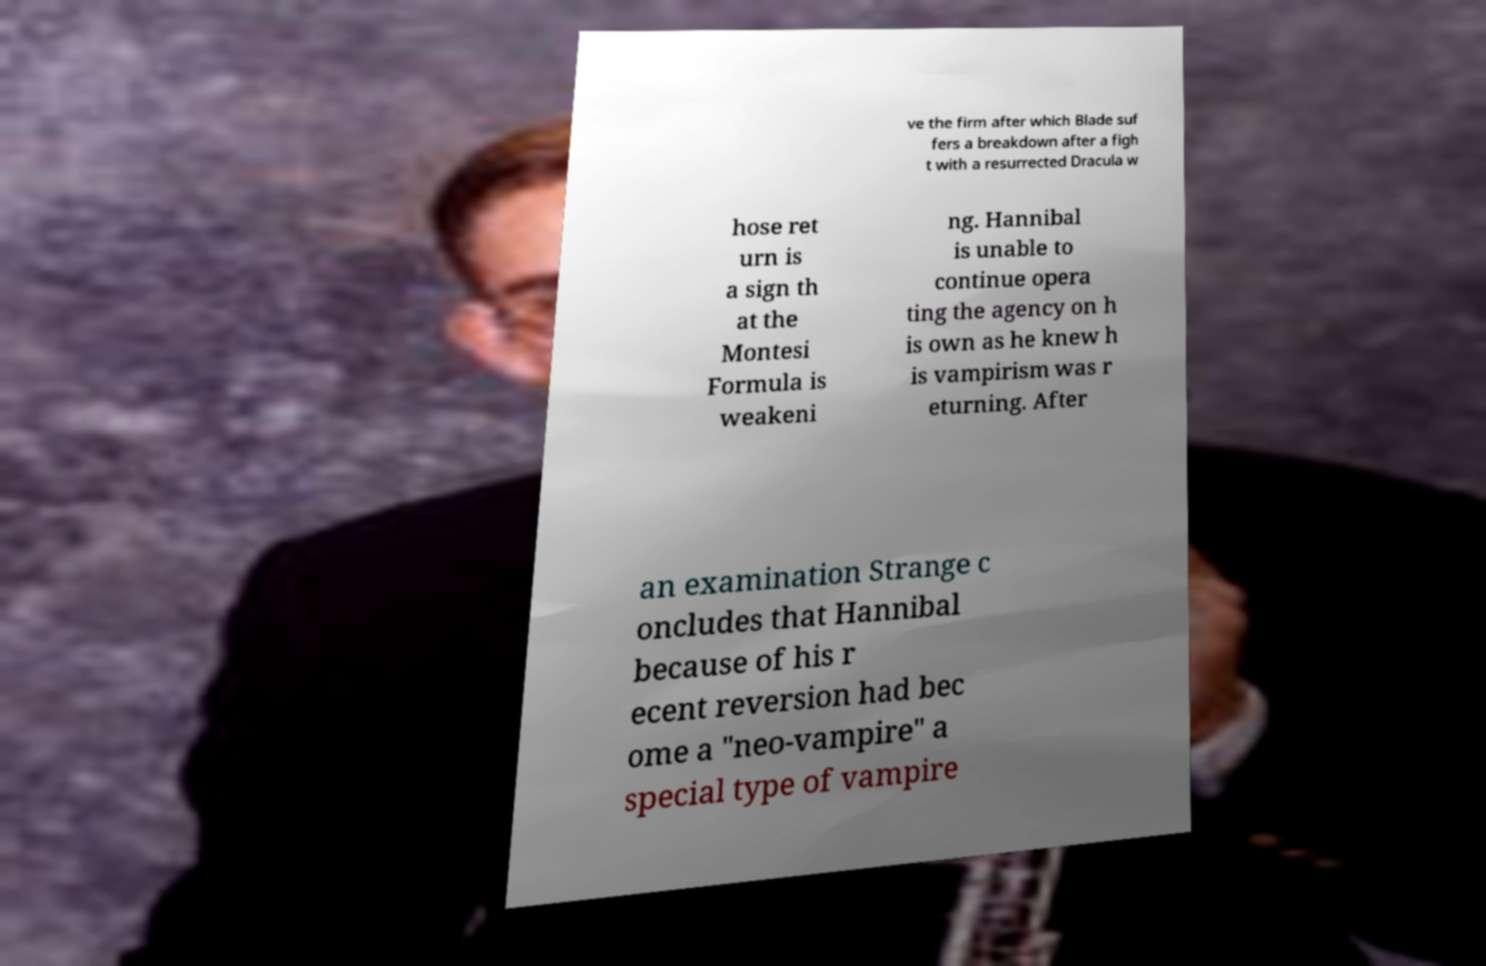Please identify and transcribe the text found in this image. ve the firm after which Blade suf fers a breakdown after a figh t with a resurrected Dracula w hose ret urn is a sign th at the Montesi Formula is weakeni ng. Hannibal is unable to continue opera ting the agency on h is own as he knew h is vampirism was r eturning. After an examination Strange c oncludes that Hannibal because of his r ecent reversion had bec ome a "neo-vampire" a special type of vampire 